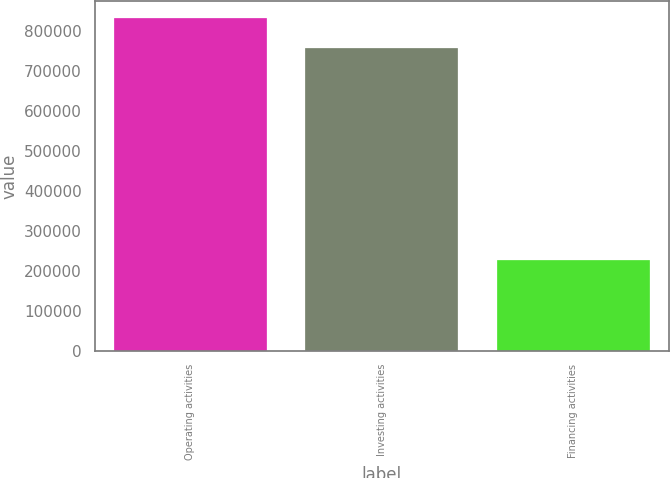Convert chart. <chart><loc_0><loc_0><loc_500><loc_500><bar_chart><fcel>Operating activities<fcel>Investing activities<fcel>Financing activities<nl><fcel>832407<fcel>756464<fcel>227058<nl></chart> 